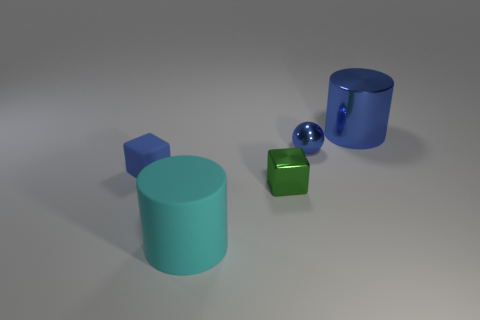Add 2 purple rubber balls. How many objects exist? 7 Subtract all cylinders. How many objects are left? 3 Subtract all small brown matte things. Subtract all blocks. How many objects are left? 3 Add 3 green metal things. How many green metal things are left? 4 Add 1 big green things. How many big green things exist? 1 Subtract 0 red blocks. How many objects are left? 5 